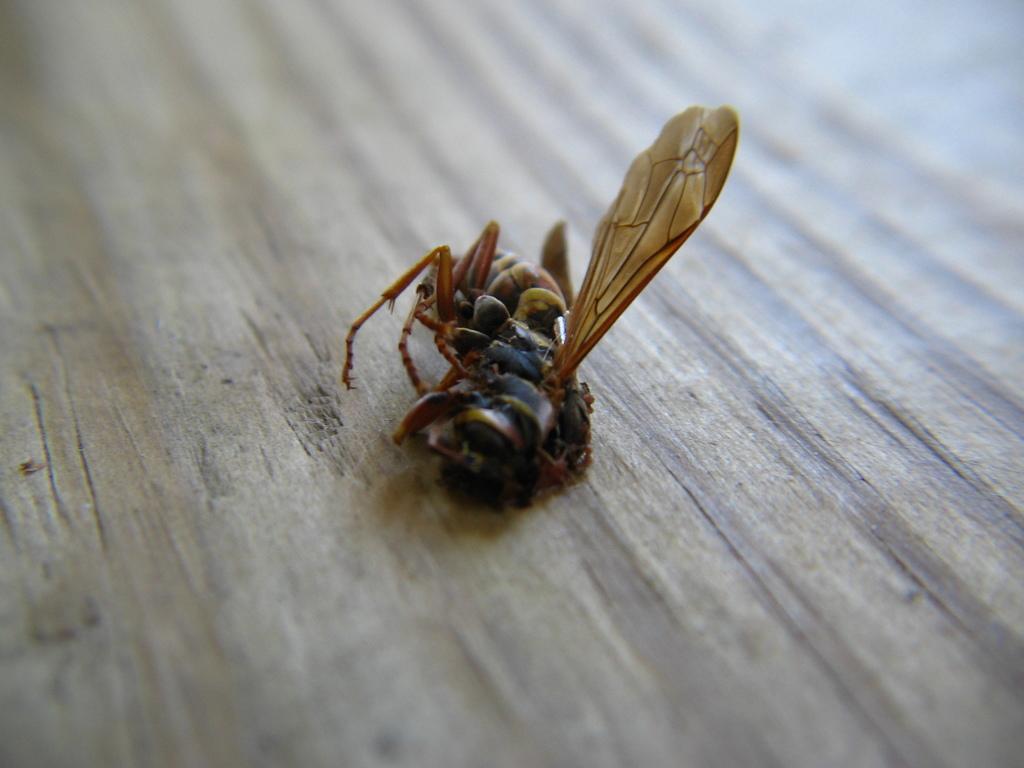Can you describe this image briefly? In this image I can see a fly on a wooden surface. 